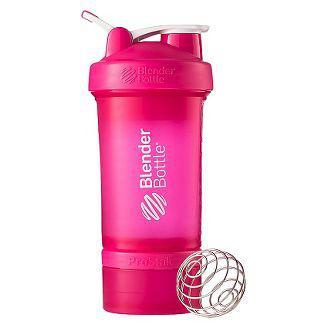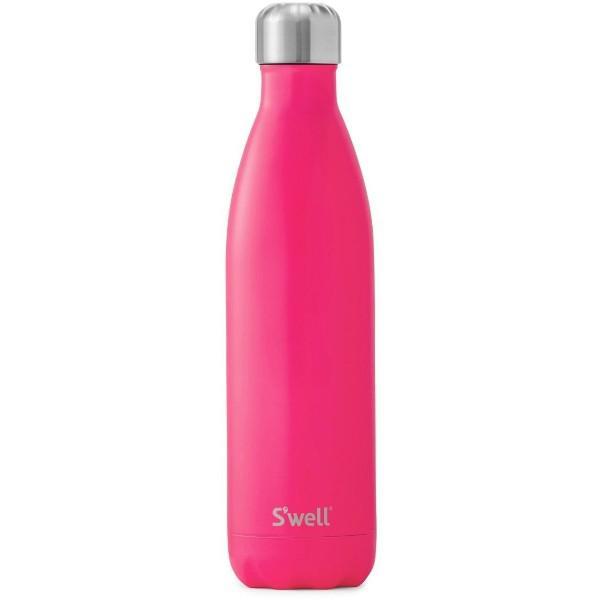The first image is the image on the left, the second image is the image on the right. For the images shown, is this caption "At least one of the bottles in the image is pink." true? Answer yes or no. Yes. 